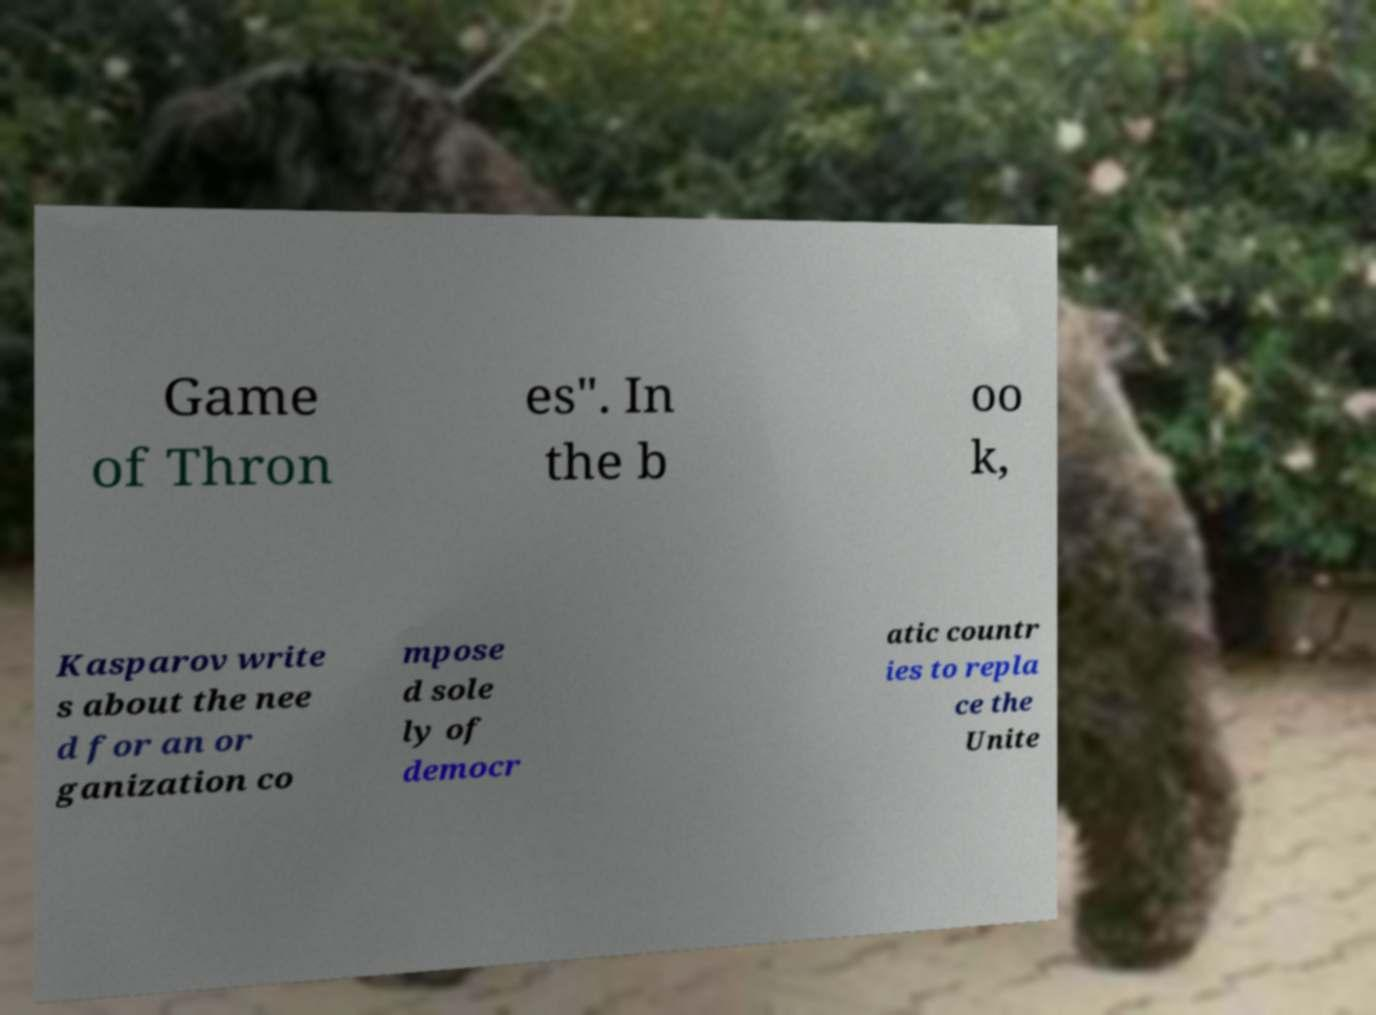Can you read and provide the text displayed in the image?This photo seems to have some interesting text. Can you extract and type it out for me? Game of Thron es". In the b oo k, Kasparov write s about the nee d for an or ganization co mpose d sole ly of democr atic countr ies to repla ce the Unite 